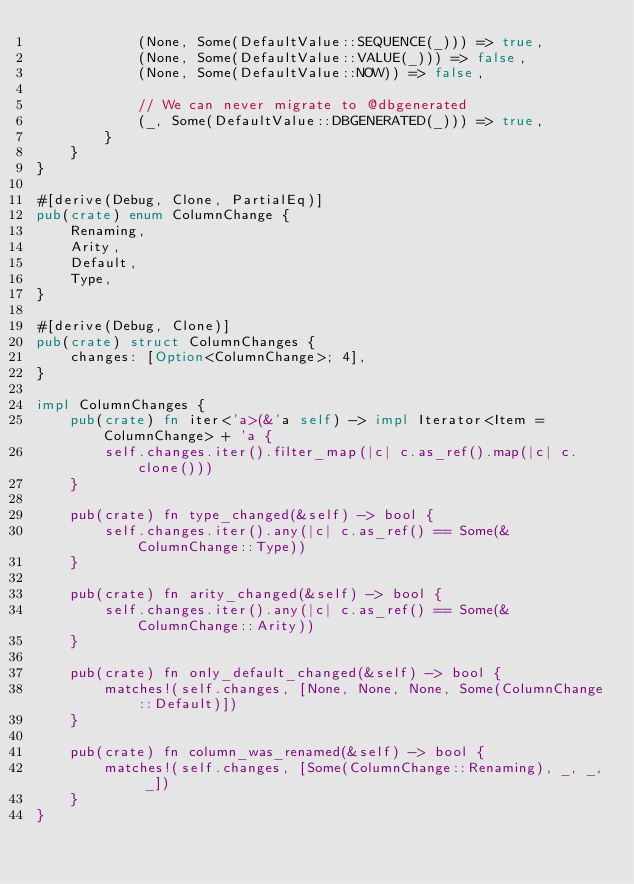Convert code to text. <code><loc_0><loc_0><loc_500><loc_500><_Rust_>            (None, Some(DefaultValue::SEQUENCE(_))) => true,
            (None, Some(DefaultValue::VALUE(_))) => false,
            (None, Some(DefaultValue::NOW)) => false,

            // We can never migrate to @dbgenerated
            (_, Some(DefaultValue::DBGENERATED(_))) => true,
        }
    }
}

#[derive(Debug, Clone, PartialEq)]
pub(crate) enum ColumnChange {
    Renaming,
    Arity,
    Default,
    Type,
}

#[derive(Debug, Clone)]
pub(crate) struct ColumnChanges {
    changes: [Option<ColumnChange>; 4],
}

impl ColumnChanges {
    pub(crate) fn iter<'a>(&'a self) -> impl Iterator<Item = ColumnChange> + 'a {
        self.changes.iter().filter_map(|c| c.as_ref().map(|c| c.clone()))
    }

    pub(crate) fn type_changed(&self) -> bool {
        self.changes.iter().any(|c| c.as_ref() == Some(&ColumnChange::Type))
    }

    pub(crate) fn arity_changed(&self) -> bool {
        self.changes.iter().any(|c| c.as_ref() == Some(&ColumnChange::Arity))
    }

    pub(crate) fn only_default_changed(&self) -> bool {
        matches!(self.changes, [None, None, None, Some(ColumnChange::Default)])
    }

    pub(crate) fn column_was_renamed(&self) -> bool {
        matches!(self.changes, [Some(ColumnChange::Renaming), _, _, _])
    }
}
</code> 